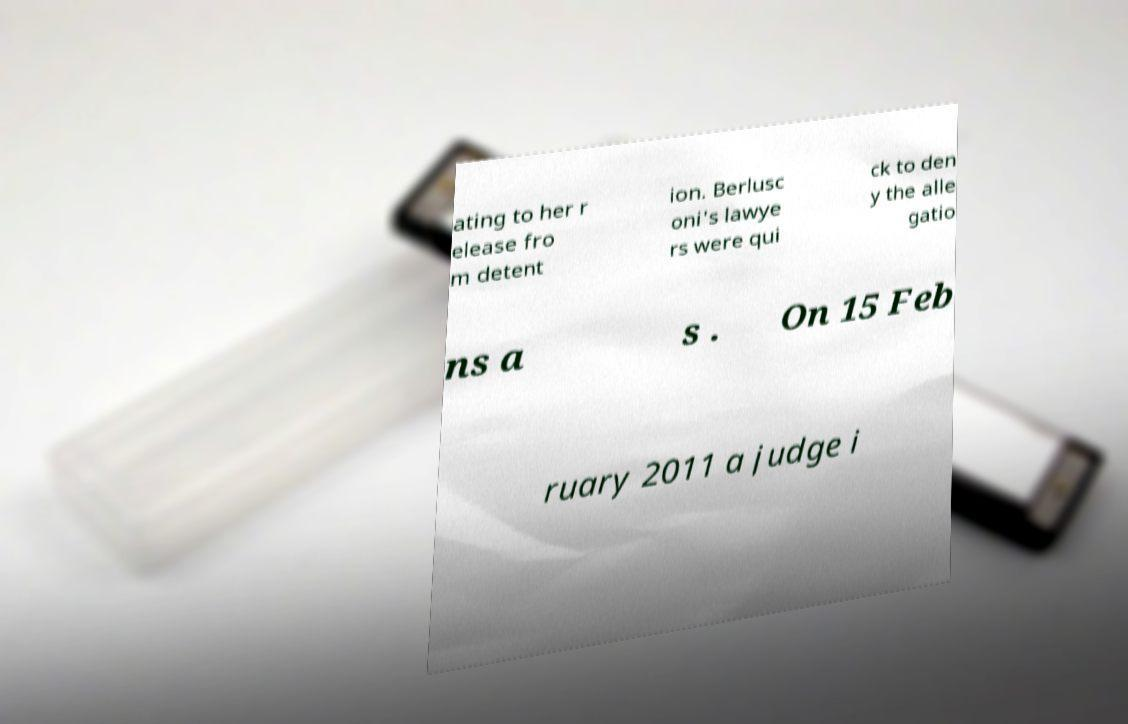I need the written content from this picture converted into text. Can you do that? ating to her r elease fro m detent ion. Berlusc oni's lawye rs were qui ck to den y the alle gatio ns a s . On 15 Feb ruary 2011 a judge i 